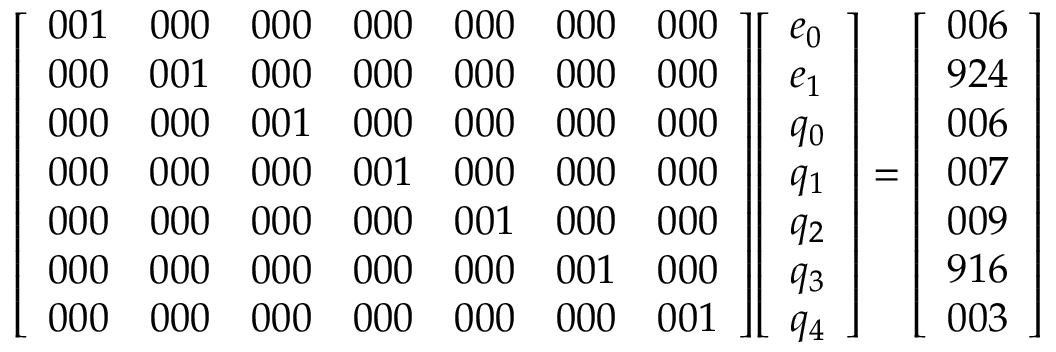<formula> <loc_0><loc_0><loc_500><loc_500>{ \left [ \begin{array} { l l l l l l l } { 0 0 1 } & { 0 0 0 } & { 0 0 0 } & { 0 0 0 } & { 0 0 0 } & { 0 0 0 } & { 0 0 0 } \\ { 0 0 0 } & { 0 0 1 } & { 0 0 0 } & { 0 0 0 } & { 0 0 0 } & { 0 0 0 } & { 0 0 0 } \\ { 0 0 0 } & { 0 0 0 } & { 0 0 1 } & { 0 0 0 } & { 0 0 0 } & { 0 0 0 } & { 0 0 0 } \\ { 0 0 0 } & { 0 0 0 } & { 0 0 0 } & { 0 0 1 } & { 0 0 0 } & { 0 0 0 } & { 0 0 0 } \\ { 0 0 0 } & { 0 0 0 } & { 0 0 0 } & { 0 0 0 } & { 0 0 1 } & { 0 0 0 } & { 0 0 0 } \\ { 0 0 0 } & { 0 0 0 } & { 0 0 0 } & { 0 0 0 } & { 0 0 0 } & { 0 0 1 } & { 0 0 0 } \\ { 0 0 0 } & { 0 0 0 } & { 0 0 0 } & { 0 0 0 } & { 0 0 0 } & { 0 0 0 } & { 0 0 1 } \end{array} \right ] } { \left [ \begin{array} { l } { e _ { 0 } } \\ { e _ { 1 } } \\ { q _ { 0 } } \\ { q _ { 1 } } \\ { q _ { 2 } } \\ { q _ { 3 } } \\ { q _ { 4 } } \end{array} \right ] } = { \left [ \begin{array} { l } { 0 0 6 } \\ { 9 2 4 } \\ { 0 0 6 } \\ { 0 0 7 } \\ { 0 0 9 } \\ { 9 1 6 } \\ { 0 0 3 } \end{array} \right ] }</formula> 